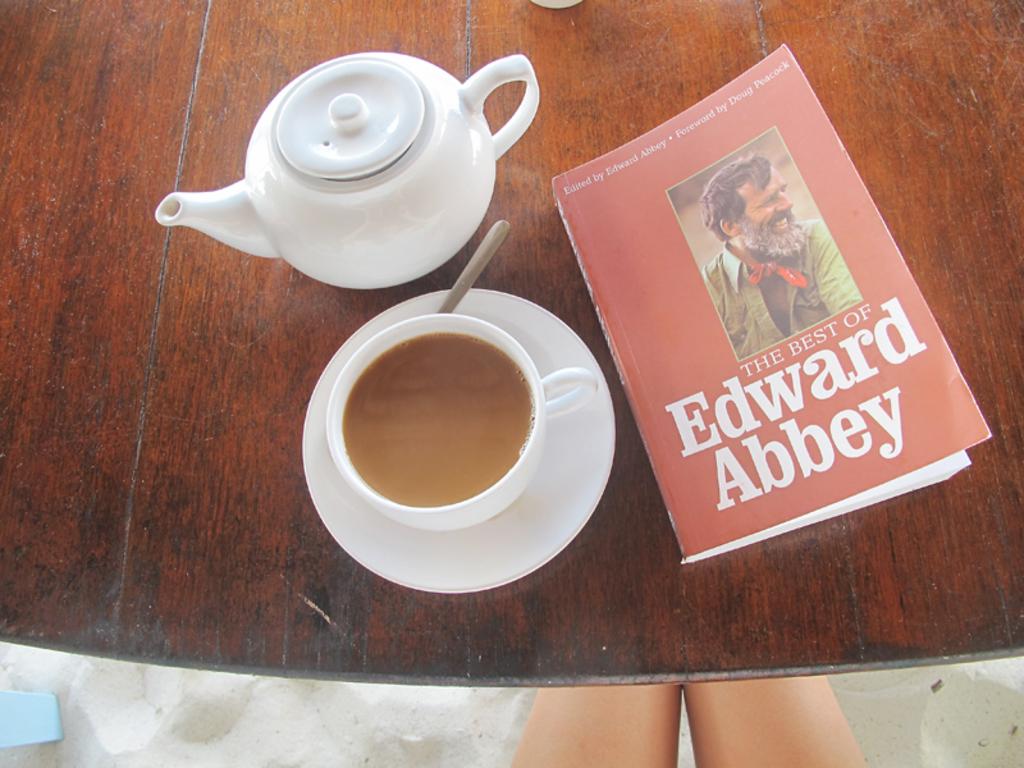Who is edward abbey?
Offer a very short reply. Unanswerable. What is the name of the book?
Your answer should be very brief. The best of edward abbey. 